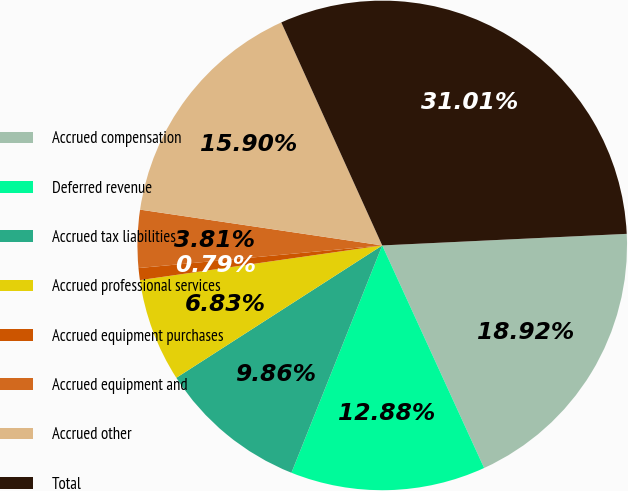Convert chart to OTSL. <chart><loc_0><loc_0><loc_500><loc_500><pie_chart><fcel>Accrued compensation<fcel>Deferred revenue<fcel>Accrued tax liabilities<fcel>Accrued professional services<fcel>Accrued equipment purchases<fcel>Accrued equipment and<fcel>Accrued other<fcel>Total<nl><fcel>18.92%<fcel>12.88%<fcel>9.86%<fcel>6.83%<fcel>0.79%<fcel>3.81%<fcel>15.9%<fcel>31.01%<nl></chart> 